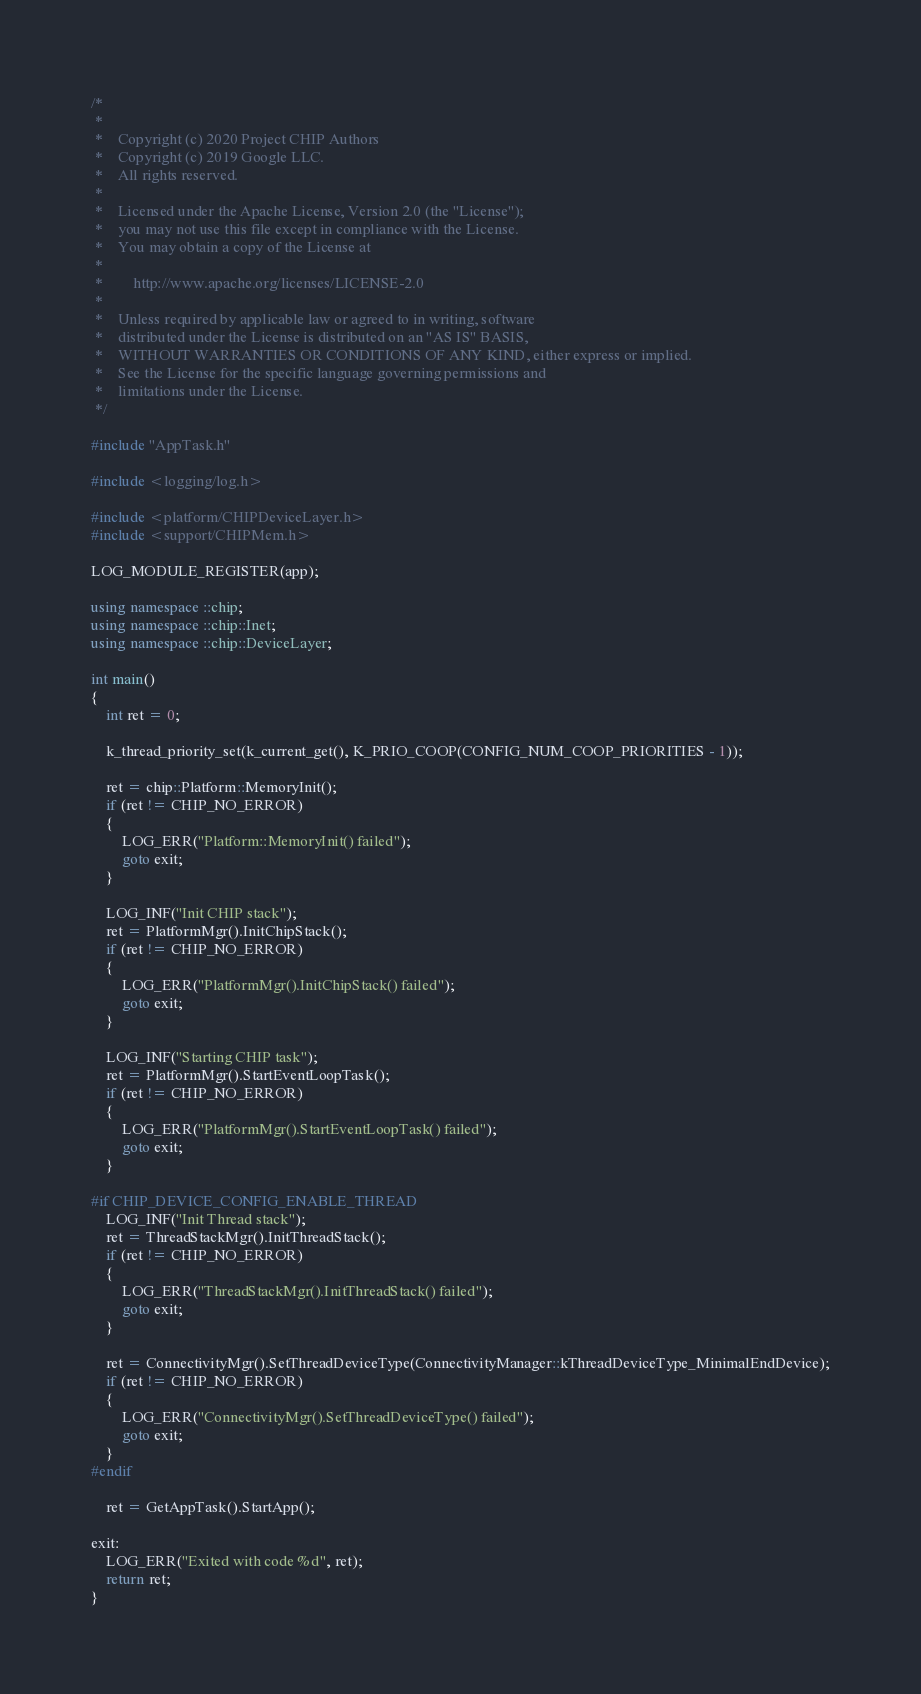Convert code to text. <code><loc_0><loc_0><loc_500><loc_500><_C++_>/*
 *
 *    Copyright (c) 2020 Project CHIP Authors
 *    Copyright (c) 2019 Google LLC.
 *    All rights reserved.
 *
 *    Licensed under the Apache License, Version 2.0 (the "License");
 *    you may not use this file except in compliance with the License.
 *    You may obtain a copy of the License at
 *
 *        http://www.apache.org/licenses/LICENSE-2.0
 *
 *    Unless required by applicable law or agreed to in writing, software
 *    distributed under the License is distributed on an "AS IS" BASIS,
 *    WITHOUT WARRANTIES OR CONDITIONS OF ANY KIND, either express or implied.
 *    See the License for the specific language governing permissions and
 *    limitations under the License.
 */

#include "AppTask.h"

#include <logging/log.h>

#include <platform/CHIPDeviceLayer.h>
#include <support/CHIPMem.h>

LOG_MODULE_REGISTER(app);

using namespace ::chip;
using namespace ::chip::Inet;
using namespace ::chip::DeviceLayer;

int main()
{
    int ret = 0;

    k_thread_priority_set(k_current_get(), K_PRIO_COOP(CONFIG_NUM_COOP_PRIORITIES - 1));

    ret = chip::Platform::MemoryInit();
    if (ret != CHIP_NO_ERROR)
    {
        LOG_ERR("Platform::MemoryInit() failed");
        goto exit;
    }

    LOG_INF("Init CHIP stack");
    ret = PlatformMgr().InitChipStack();
    if (ret != CHIP_NO_ERROR)
    {
        LOG_ERR("PlatformMgr().InitChipStack() failed");
        goto exit;
    }

    LOG_INF("Starting CHIP task");
    ret = PlatformMgr().StartEventLoopTask();
    if (ret != CHIP_NO_ERROR)
    {
        LOG_ERR("PlatformMgr().StartEventLoopTask() failed");
        goto exit;
    }

#if CHIP_DEVICE_CONFIG_ENABLE_THREAD
    LOG_INF("Init Thread stack");
    ret = ThreadStackMgr().InitThreadStack();
    if (ret != CHIP_NO_ERROR)
    {
        LOG_ERR("ThreadStackMgr().InitThreadStack() failed");
        goto exit;
    }

    ret = ConnectivityMgr().SetThreadDeviceType(ConnectivityManager::kThreadDeviceType_MinimalEndDevice);
    if (ret != CHIP_NO_ERROR)
    {
        LOG_ERR("ConnectivityMgr().SetThreadDeviceType() failed");
        goto exit;
    }
#endif

    ret = GetAppTask().StartApp();

exit:
    LOG_ERR("Exited with code %d", ret);
    return ret;
}
</code> 